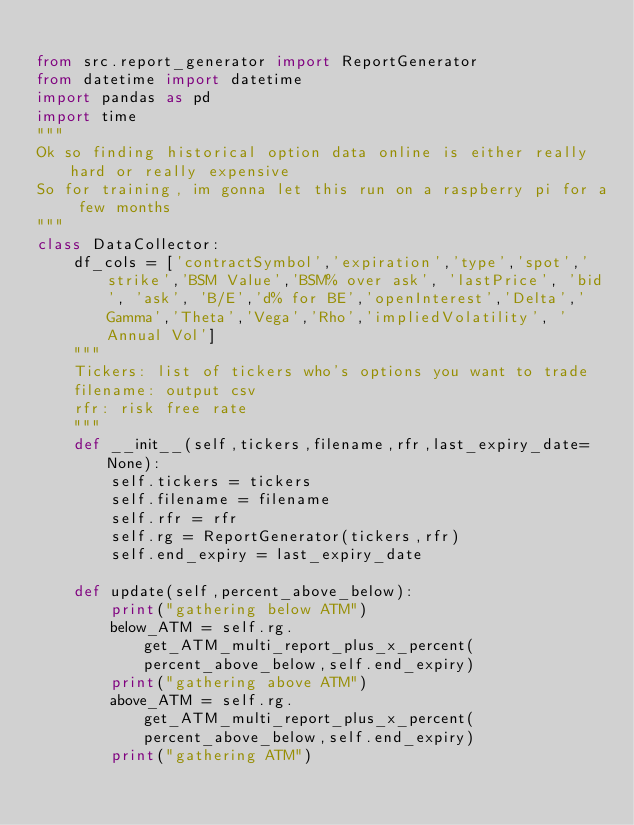Convert code to text. <code><loc_0><loc_0><loc_500><loc_500><_Python_>
from src.report_generator import ReportGenerator
from datetime import datetime
import pandas as pd
import time
"""
Ok so finding historical option data online is either really hard or really expensive
So for training, im gonna let this run on a raspberry pi for a few months
"""
class DataCollector:
    df_cols = ['contractSymbol','expiration','type','spot','strike','BSM Value','BSM% over ask', 'lastPrice', 'bid', 'ask', 'B/E','d% for BE','openInterest','Delta','Gamma','Theta','Vega','Rho','impliedVolatility', 'Annual Vol']
    """
    Tickers: list of tickers who's options you want to trade
    filename: output csv
    rfr: risk free rate
    """
    def __init__(self,tickers,filename,rfr,last_expiry_date=None):
        self.tickers = tickers
        self.filename = filename
        self.rfr = rfr
        self.rg = ReportGenerator(tickers,rfr)
        self.end_expiry = last_expiry_date
    
    def update(self,percent_above_below):
        print("gathering below ATM")
        below_ATM = self.rg.get_ATM_multi_report_plus_x_percent(percent_above_below,self.end_expiry)
        print("gathering above ATM")
        above_ATM = self.rg.get_ATM_multi_report_plus_x_percent(percent_above_below,self.end_expiry)
        print("gathering ATM")</code> 